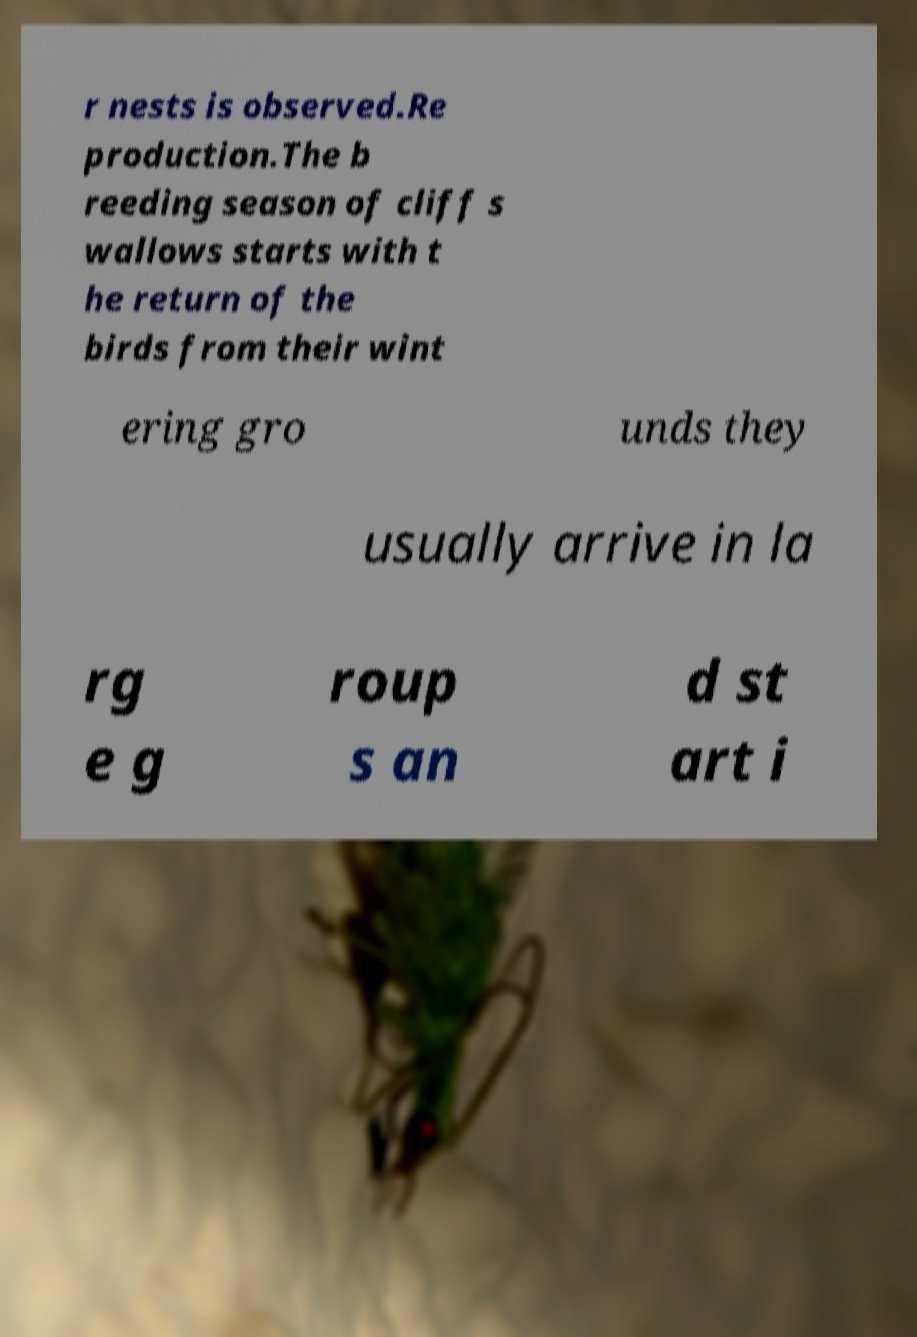Can you read and provide the text displayed in the image?This photo seems to have some interesting text. Can you extract and type it out for me? r nests is observed.Re production.The b reeding season of cliff s wallows starts with t he return of the birds from their wint ering gro unds they usually arrive in la rg e g roup s an d st art i 